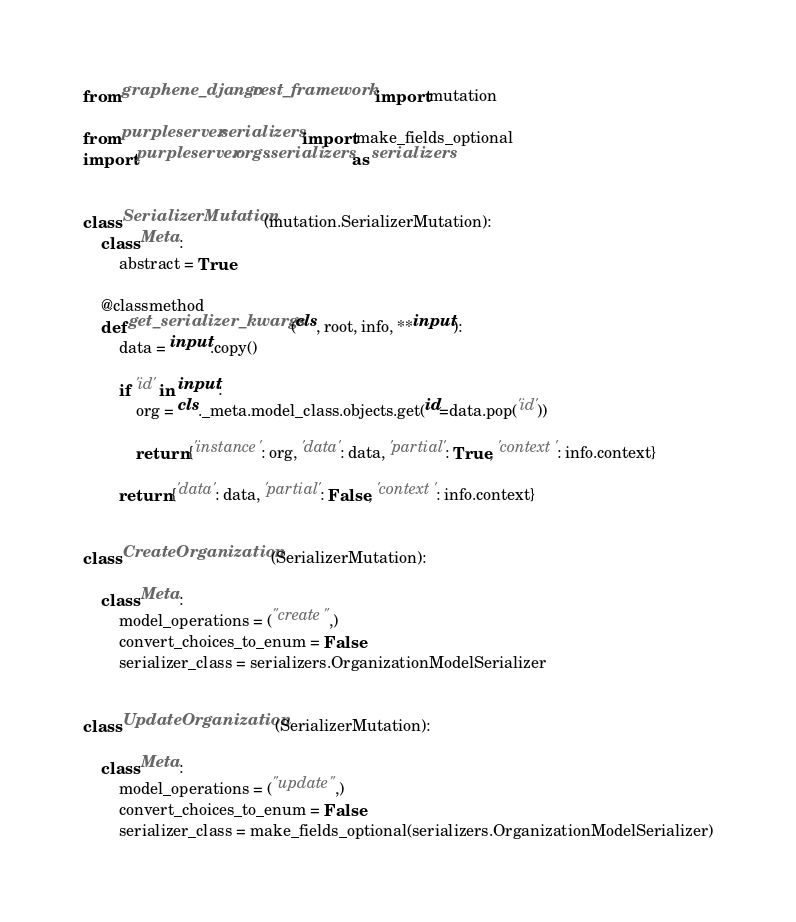<code> <loc_0><loc_0><loc_500><loc_500><_Python_>from graphene_django.rest_framework import mutation

from purpleserver.serializers import make_fields_optional
import purpleserver.orgs.serializers as serializers


class SerializerMutation(mutation.SerializerMutation):
    class Meta:
        abstract = True

    @classmethod
    def get_serializer_kwargs(cls, root, info, **input):
        data = input.copy()

        if 'id' in input:
            org = cls._meta.model_class.objects.get(id=data.pop('id'))

            return {'instance': org, 'data': data, 'partial': True, 'context': info.context}

        return {'data': data, 'partial': False, 'context': info.context}


class CreateOrganization(SerializerMutation):

    class Meta:
        model_operations = ("create",)
        convert_choices_to_enum = False
        serializer_class = serializers.OrganizationModelSerializer


class UpdateOrganization(SerializerMutation):

    class Meta:
        model_operations = ("update",)
        convert_choices_to_enum = False
        serializer_class = make_fields_optional(serializers.OrganizationModelSerializer)
</code> 